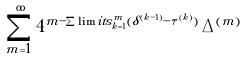<formula> <loc_0><loc_0><loc_500><loc_500>\sum _ { m = 1 } ^ { \infty } 4 ^ { m - \sum \lim i t s _ { k = 1 } ^ { m } ( \delta ^ { ( k - 1 ) } - \tau ^ { ( k ) } ) } \, \Delta ^ { ( m ) }</formula> 